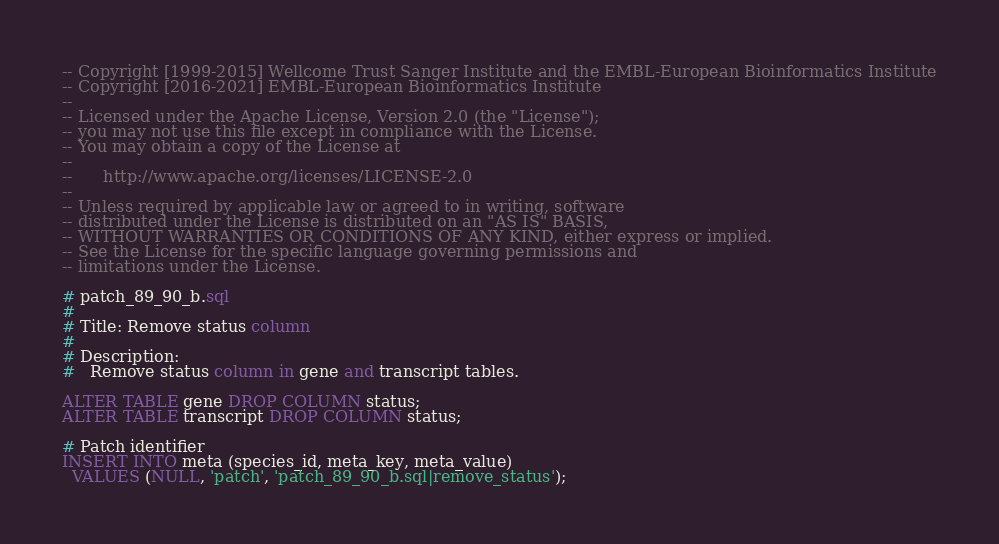<code> <loc_0><loc_0><loc_500><loc_500><_SQL_>-- Copyright [1999-2015] Wellcome Trust Sanger Institute and the EMBL-European Bioinformatics Institute
-- Copyright [2016-2021] EMBL-European Bioinformatics Institute
--
-- Licensed under the Apache License, Version 2.0 (the "License");
-- you may not use this file except in compliance with the License.
-- You may obtain a copy of the License at
--
--      http://www.apache.org/licenses/LICENSE-2.0
--
-- Unless required by applicable law or agreed to in writing, software
-- distributed under the License is distributed on an "AS IS" BASIS,
-- WITHOUT WARRANTIES OR CONDITIONS OF ANY KIND, either express or implied.
-- See the License for the specific language governing permissions and
-- limitations under the License.

# patch_89_90_b.sql
#
# Title: Remove status column
#
# Description:
#   Remove status column in gene and transcript tables.

ALTER TABLE gene DROP COLUMN status;
ALTER TABLE transcript DROP COLUMN status;

# Patch identifier
INSERT INTO meta (species_id, meta_key, meta_value)
  VALUES (NULL, 'patch', 'patch_89_90_b.sql|remove_status');
</code> 